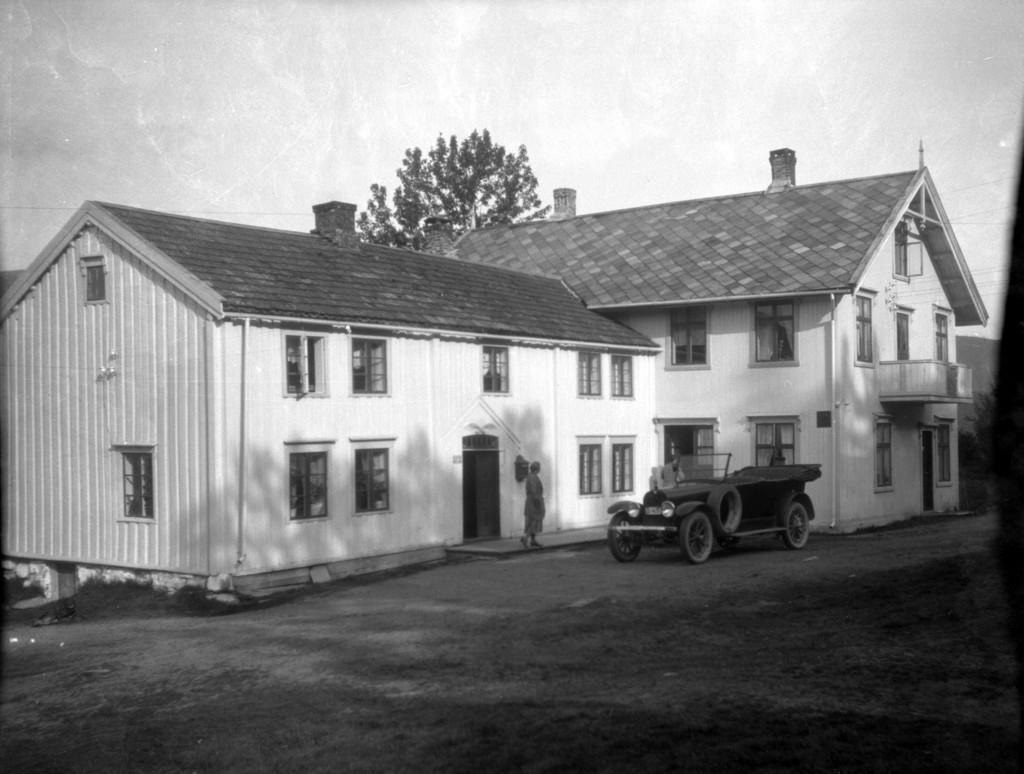In one or two sentences, can you explain what this image depicts? In the picture we can see a house building side by side and we can see some windows and doors to it and just beside we can see a person standing and some vintage car parked near to it, in the background we can see a part of a tree and sky. 